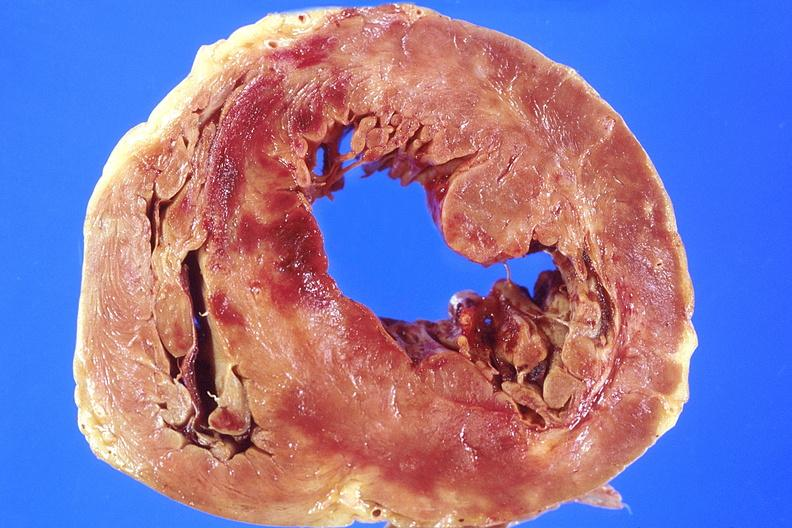s very good example present?
Answer the question using a single word or phrase. No 